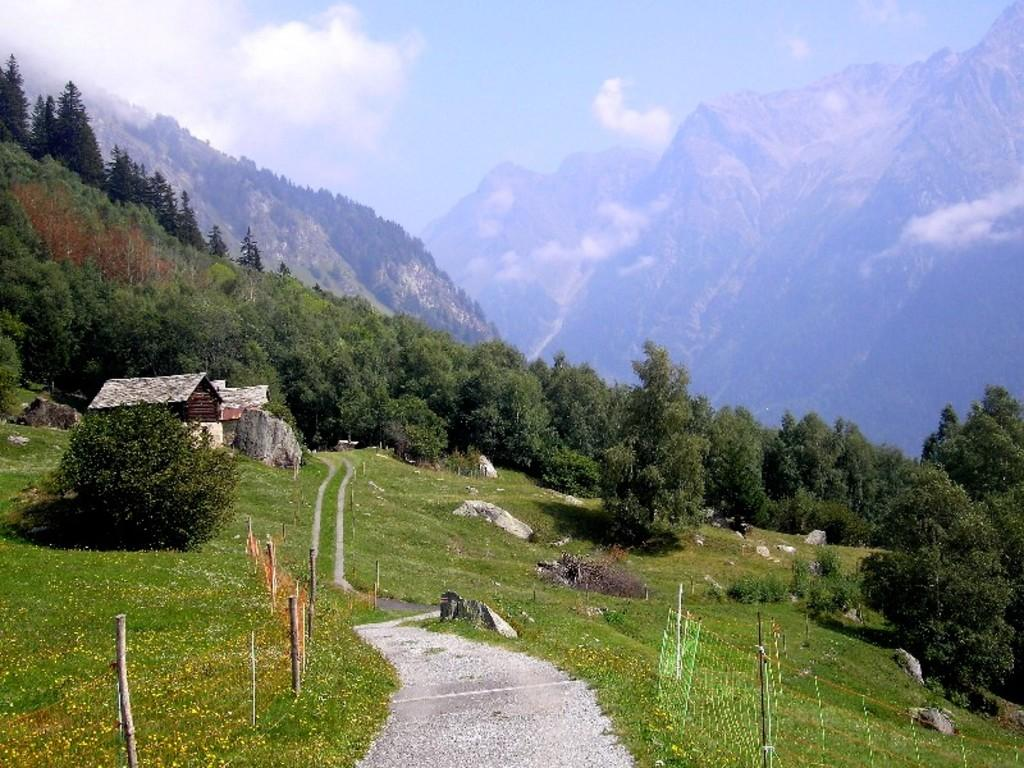What is the main feature of the image? There is a way or path in the image. What can be seen on either side of the path? There is greenery on either side of the path. What is visible in the background of the image? There are trees and mountains in the background of the image. Can you tell me how many donkeys are pulling a cart along the path in the image? There are no donkeys or carts present in the image; it only features a path with greenery on either side and trees and mountains in the background. What type of steam is visible coming from the mountains in the image? There is no steam visible in the image; it only features a path with greenery on either side and trees and mountains in the background. 